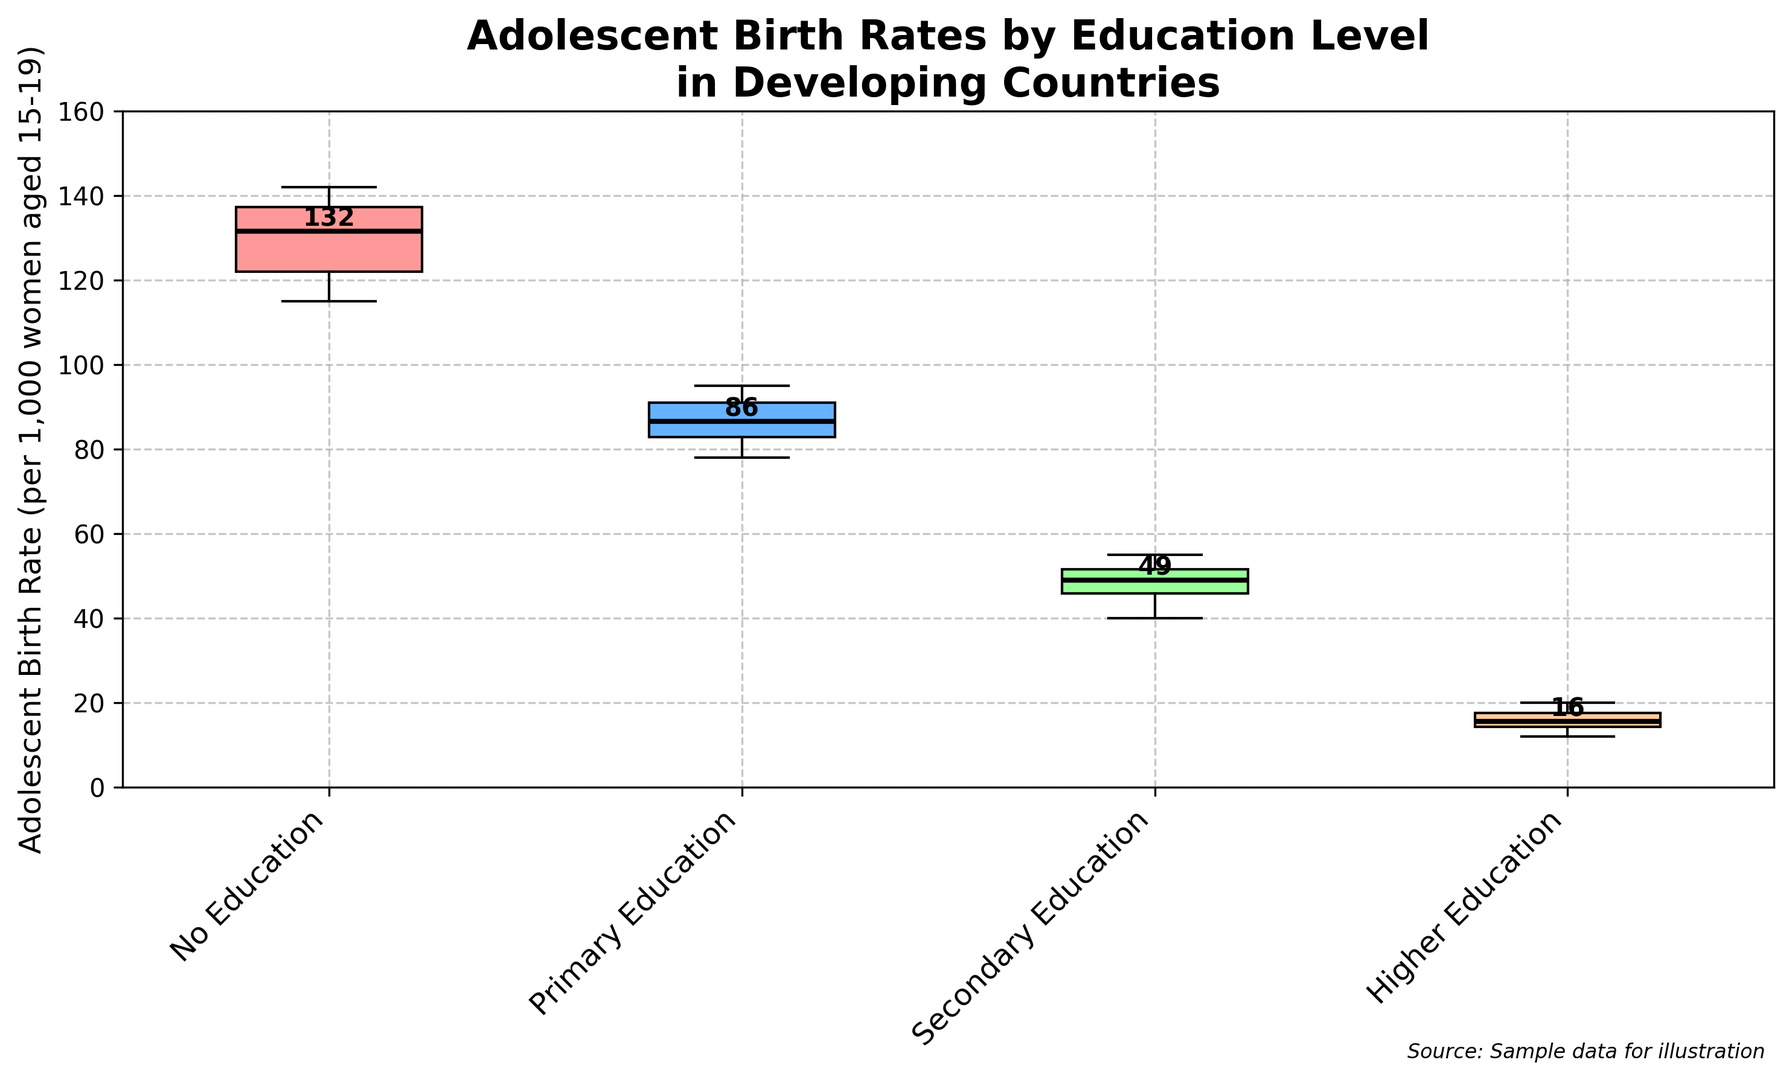What is the median adolescent birth rate for those with no education? Look at the box corresponding to "No Education" and identify the line in the middle of the boxplot, which represents the median.
Answer: 130 How does the median birth rate for those with primary education compare to those with secondary education? Compare the median lines in the middle of the boxplots for "Primary Education" and "Secondary Education." The median for primary education is higher than the median for secondary education.
Answer: Higher Which education level has the lowest median adolescent birth rate? Identify the education level where the middle line of the boxplot (median) is at the lowest point.
Answer: Higher Education What is the range of adolescent birth rates for those with no education? The range is determined by the distance between the lowest and highest points (whiskers) of the "No Education" boxplot.
Answer: 115-142 What color represents the secondary education boxplot? Observe the color of the boxplot corresponding to "Secondary Education."
Answer: Blue Is there any overlap in the interquartile range (IQR) between primary and secondary education? Look at the boxes (IQR) for "Primary Education" and "Secondary Education" and see if they overlap vertically. The top of the "Secondary Education" box and the bottom of the "Primary Education" box should be compared.
Answer: No What is the approximate median difference in birth rates between those with primary and no education? Subtract the median of "Primary Education" (88) from the median of "No Education" (130).
Answer: 42 Which education level shows the smallest variability (smallest IQR) in birth rates? Identify the education level where the box (IQR) is the narrowest from the bottom to the top.
Answer: Higher Education What are the approximate 1st and 3rd quartiles for birth rates among those with secondary education? The 1st quartile (Q1) is the bottom of the box, and the 3rd quartile (Q3) is the top of the box for "Secondary Education." Approximate these values by looking at the plot.
Answer: 45, 52 